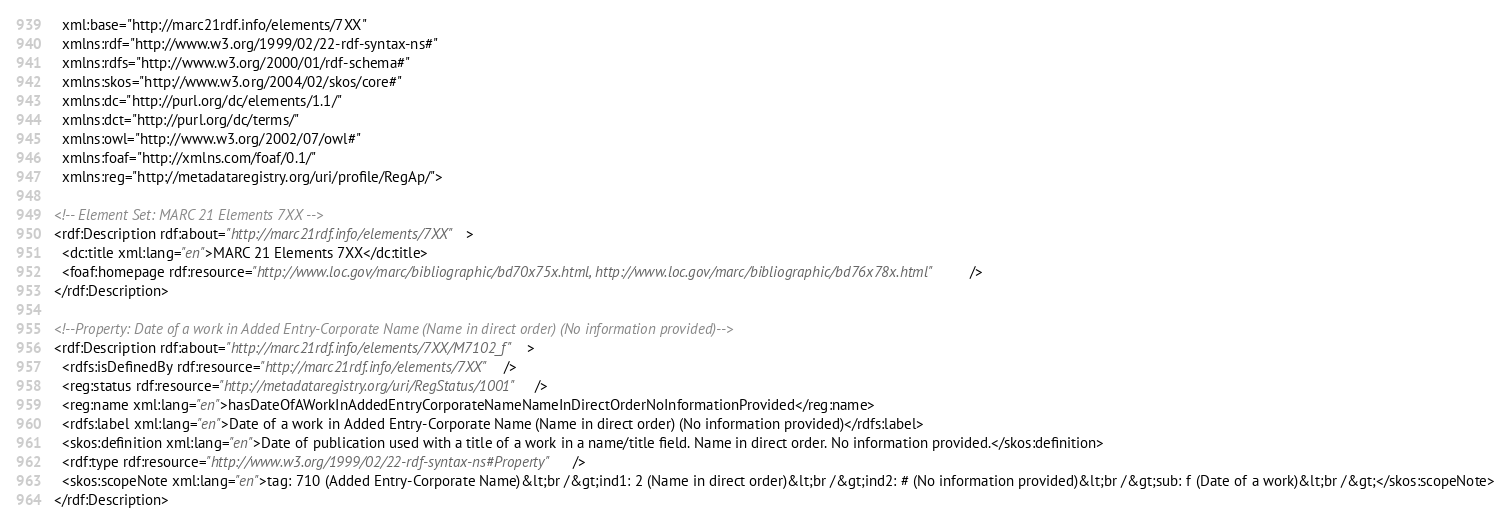<code> <loc_0><loc_0><loc_500><loc_500><_XML_>  xml:base="http://marc21rdf.info/elements/7XX"
  xmlns:rdf="http://www.w3.org/1999/02/22-rdf-syntax-ns#"
  xmlns:rdfs="http://www.w3.org/2000/01/rdf-schema#"
  xmlns:skos="http://www.w3.org/2004/02/skos/core#"
  xmlns:dc="http://purl.org/dc/elements/1.1/"
  xmlns:dct="http://purl.org/dc/terms/"
  xmlns:owl="http://www.w3.org/2002/07/owl#"
  xmlns:foaf="http://xmlns.com/foaf/0.1/"
  xmlns:reg="http://metadataregistry.org/uri/profile/RegAp/">

<!-- Element Set: MARC 21 Elements 7XX -->
<rdf:Description rdf:about="http://marc21rdf.info/elements/7XX">
  <dc:title xml:lang="en">MARC 21 Elements 7XX</dc:title>
  <foaf:homepage rdf:resource="http://www.loc.gov/marc/bibliographic/bd70x75x.html, http://www.loc.gov/marc/bibliographic/bd76x78x.html"/>
</rdf:Description>

<!--Property: Date of a work in Added Entry-Corporate Name (Name in direct order) (No information provided)-->
<rdf:Description rdf:about="http://marc21rdf.info/elements/7XX/M7102_f">
  <rdfs:isDefinedBy rdf:resource="http://marc21rdf.info/elements/7XX" />
  <reg:status rdf:resource="http://metadataregistry.org/uri/RegStatus/1001" />
  <reg:name xml:lang="en">hasDateOfAWorkInAddedEntryCorporateNameNameInDirectOrderNoInformationProvided</reg:name>
  <rdfs:label xml:lang="en">Date of a work in Added Entry-Corporate Name (Name in direct order) (No information provided)</rdfs:label>
  <skos:definition xml:lang="en">Date of publication used with a title of a work in a name/title field. Name in direct order. No information provided.</skos:definition>
  <rdf:type rdf:resource="http://www.w3.org/1999/02/22-rdf-syntax-ns#Property" />
  <skos:scopeNote xml:lang="en">tag: 710 (Added Entry-Corporate Name)&lt;br /&gt;ind1: 2 (Name in direct order)&lt;br /&gt;ind2: # (No information provided)&lt;br /&gt;sub: f (Date of a work)&lt;br /&gt;</skos:scopeNote>
</rdf:Description>
</code> 